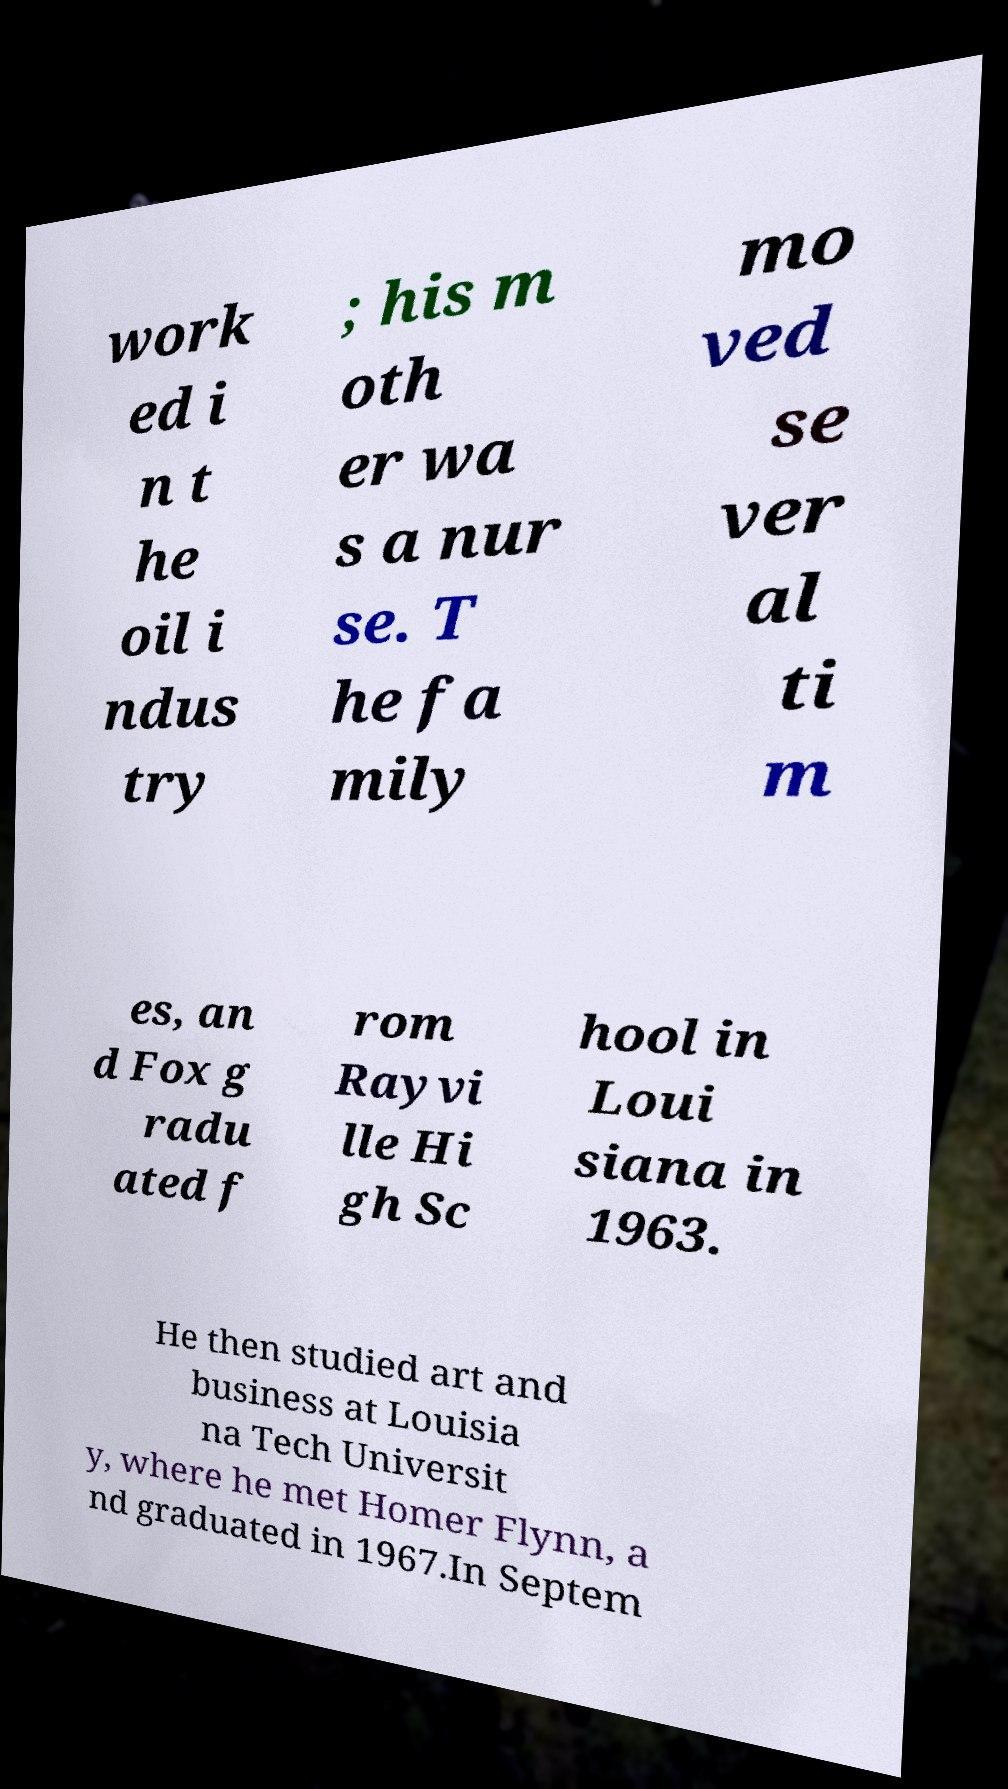What messages or text are displayed in this image? I need them in a readable, typed format. work ed i n t he oil i ndus try ; his m oth er wa s a nur se. T he fa mily mo ved se ver al ti m es, an d Fox g radu ated f rom Rayvi lle Hi gh Sc hool in Loui siana in 1963. He then studied art and business at Louisia na Tech Universit y, where he met Homer Flynn, a nd graduated in 1967.In Septem 